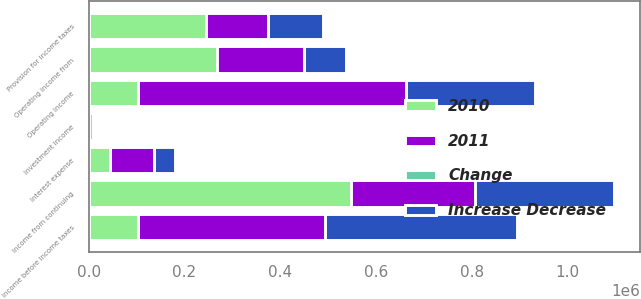<chart> <loc_0><loc_0><loc_500><loc_500><stacked_bar_chart><ecel><fcel>Operating income from<fcel>Operating income<fcel>Investment income<fcel>Interest expense<fcel>Income before income taxes<fcel>Provision for income taxes<fcel>Income from continuing<nl><fcel>2010<fcel>268791<fcel>102072<fcel>7963<fcel>45266<fcel>102072<fcel>244586<fcel>548078<nl><fcel>2011<fcel>181873<fcel>560631<fcel>5442<fcel>90357<fcel>390469<fcel>130800<fcel>259669<nl><fcel>Increase Decrease<fcel>86918<fcel>269336<fcel>2521<fcel>45091<fcel>402195<fcel>113786<fcel>288409<nl><fcel>Change<fcel>47.8<fcel>48<fcel>46.3<fcel>49.9<fcel>103<fcel>87<fcel>111.1<nl></chart> 